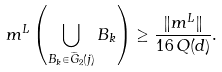<formula> <loc_0><loc_0><loc_500><loc_500>m ^ { L } \left ( \bigcup _ { B _ { k } \in \widetilde { G } _ { 2 } ( j ) } B _ { k } \right ) \geq \frac { \| m ^ { L } \| } { 1 6 \, Q ( d ) } .</formula> 